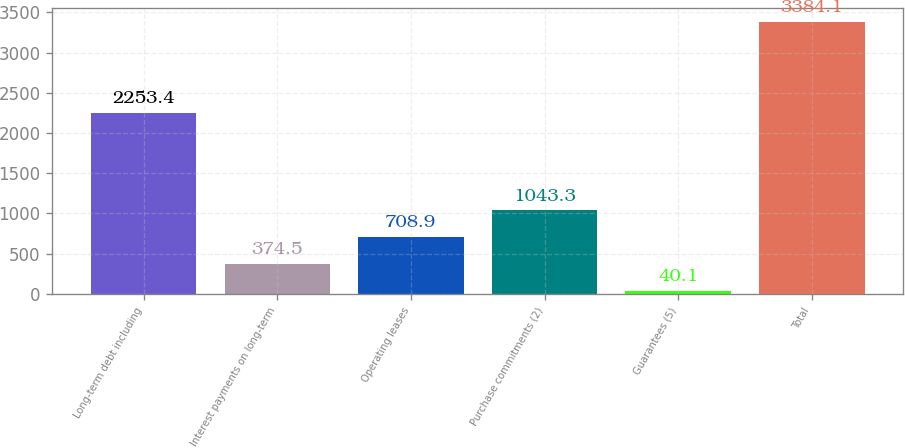Convert chart to OTSL. <chart><loc_0><loc_0><loc_500><loc_500><bar_chart><fcel>Long-term debt including<fcel>Interest payments on long-term<fcel>Operating leases<fcel>Purchase commitments (2)<fcel>Guarantees (5)<fcel>Total<nl><fcel>2253.4<fcel>374.5<fcel>708.9<fcel>1043.3<fcel>40.1<fcel>3384.1<nl></chart> 